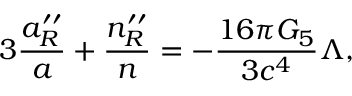<formula> <loc_0><loc_0><loc_500><loc_500>3 { \frac { a _ { R } ^ { \prime \prime } } { a } } + { \frac { n _ { R } ^ { \prime \prime } } { n } } = - { \frac { 1 6 \pi G _ { 5 } } { 3 c ^ { 4 } } } \Lambda ,</formula> 